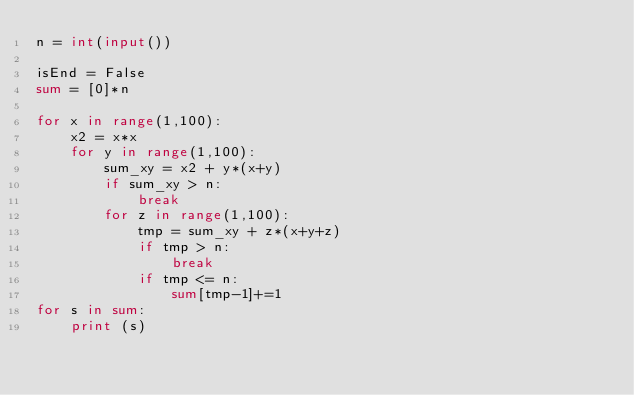Convert code to text. <code><loc_0><loc_0><loc_500><loc_500><_Python_>n = int(input())

isEnd = False
sum = [0]*n

for x in range(1,100):
    x2 = x*x
    for y in range(1,100):
        sum_xy = x2 + y*(x+y)
        if sum_xy > n:
            break
        for z in range(1,100):
            tmp = sum_xy + z*(x+y+z)
            if tmp > n:
                break
            if tmp <= n:
                sum[tmp-1]+=1
for s in sum:
    print (s)</code> 